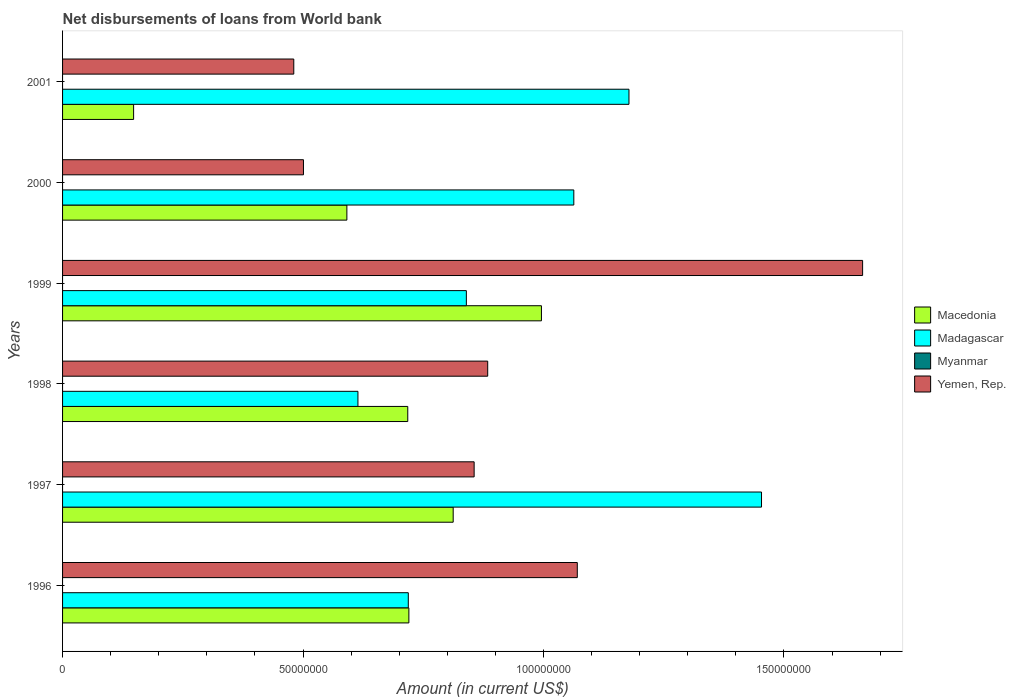How many different coloured bars are there?
Your answer should be compact. 3. How many groups of bars are there?
Give a very brief answer. 6. Are the number of bars per tick equal to the number of legend labels?
Your answer should be compact. No. How many bars are there on the 3rd tick from the top?
Your response must be concise. 3. In how many cases, is the number of bars for a given year not equal to the number of legend labels?
Offer a very short reply. 6. What is the amount of loan disbursed from World Bank in Yemen, Rep. in 1999?
Your answer should be compact. 1.66e+08. Across all years, what is the maximum amount of loan disbursed from World Bank in Macedonia?
Provide a succinct answer. 9.96e+07. Across all years, what is the minimum amount of loan disbursed from World Bank in Myanmar?
Give a very brief answer. 0. In which year was the amount of loan disbursed from World Bank in Yemen, Rep. maximum?
Provide a short and direct response. 1999. What is the total amount of loan disbursed from World Bank in Macedonia in the graph?
Ensure brevity in your answer.  3.98e+08. What is the difference between the amount of loan disbursed from World Bank in Yemen, Rep. in 1996 and that in 1997?
Provide a succinct answer. 2.14e+07. What is the difference between the amount of loan disbursed from World Bank in Myanmar in 1998 and the amount of loan disbursed from World Bank in Yemen, Rep. in 2001?
Your answer should be very brief. -4.81e+07. What is the average amount of loan disbursed from World Bank in Madagascar per year?
Provide a short and direct response. 9.78e+07. In the year 2000, what is the difference between the amount of loan disbursed from World Bank in Macedonia and amount of loan disbursed from World Bank in Madagascar?
Offer a terse response. -4.72e+07. In how many years, is the amount of loan disbursed from World Bank in Macedonia greater than 80000000 US$?
Provide a succinct answer. 2. What is the ratio of the amount of loan disbursed from World Bank in Madagascar in 1998 to that in 1999?
Your response must be concise. 0.73. Is the amount of loan disbursed from World Bank in Macedonia in 1999 less than that in 2000?
Make the answer very short. No. Is the difference between the amount of loan disbursed from World Bank in Macedonia in 1997 and 2000 greater than the difference between the amount of loan disbursed from World Bank in Madagascar in 1997 and 2000?
Your answer should be very brief. No. What is the difference between the highest and the second highest amount of loan disbursed from World Bank in Yemen, Rep.?
Provide a succinct answer. 5.93e+07. What is the difference between the highest and the lowest amount of loan disbursed from World Bank in Yemen, Rep.?
Keep it short and to the point. 1.18e+08. Is the sum of the amount of loan disbursed from World Bank in Macedonia in 1996 and 2000 greater than the maximum amount of loan disbursed from World Bank in Madagascar across all years?
Your answer should be compact. No. Is it the case that in every year, the sum of the amount of loan disbursed from World Bank in Macedonia and amount of loan disbursed from World Bank in Yemen, Rep. is greater than the sum of amount of loan disbursed from World Bank in Madagascar and amount of loan disbursed from World Bank in Myanmar?
Your response must be concise. No. How many bars are there?
Offer a very short reply. 18. How many years are there in the graph?
Keep it short and to the point. 6. Does the graph contain grids?
Ensure brevity in your answer.  No. How many legend labels are there?
Offer a terse response. 4. How are the legend labels stacked?
Give a very brief answer. Vertical. What is the title of the graph?
Ensure brevity in your answer.  Net disbursements of loans from World bank. What is the label or title of the X-axis?
Offer a terse response. Amount (in current US$). What is the Amount (in current US$) of Macedonia in 1996?
Ensure brevity in your answer.  7.20e+07. What is the Amount (in current US$) in Madagascar in 1996?
Provide a short and direct response. 7.19e+07. What is the Amount (in current US$) of Myanmar in 1996?
Provide a short and direct response. 0. What is the Amount (in current US$) in Yemen, Rep. in 1996?
Offer a very short reply. 1.07e+08. What is the Amount (in current US$) of Macedonia in 1997?
Ensure brevity in your answer.  8.12e+07. What is the Amount (in current US$) in Madagascar in 1997?
Your response must be concise. 1.45e+08. What is the Amount (in current US$) in Myanmar in 1997?
Your answer should be compact. 0. What is the Amount (in current US$) of Yemen, Rep. in 1997?
Provide a short and direct response. 8.56e+07. What is the Amount (in current US$) in Macedonia in 1998?
Provide a short and direct response. 7.18e+07. What is the Amount (in current US$) of Madagascar in 1998?
Give a very brief answer. 6.14e+07. What is the Amount (in current US$) in Yemen, Rep. in 1998?
Keep it short and to the point. 8.84e+07. What is the Amount (in current US$) of Macedonia in 1999?
Ensure brevity in your answer.  9.96e+07. What is the Amount (in current US$) in Madagascar in 1999?
Your answer should be compact. 8.40e+07. What is the Amount (in current US$) of Myanmar in 1999?
Your response must be concise. 0. What is the Amount (in current US$) of Yemen, Rep. in 1999?
Keep it short and to the point. 1.66e+08. What is the Amount (in current US$) of Macedonia in 2000?
Your answer should be compact. 5.91e+07. What is the Amount (in current US$) in Madagascar in 2000?
Make the answer very short. 1.06e+08. What is the Amount (in current US$) in Yemen, Rep. in 2000?
Ensure brevity in your answer.  5.01e+07. What is the Amount (in current US$) in Macedonia in 2001?
Give a very brief answer. 1.48e+07. What is the Amount (in current US$) of Madagascar in 2001?
Provide a short and direct response. 1.18e+08. What is the Amount (in current US$) of Yemen, Rep. in 2001?
Keep it short and to the point. 4.81e+07. Across all years, what is the maximum Amount (in current US$) of Macedonia?
Keep it short and to the point. 9.96e+07. Across all years, what is the maximum Amount (in current US$) in Madagascar?
Offer a terse response. 1.45e+08. Across all years, what is the maximum Amount (in current US$) of Yemen, Rep.?
Make the answer very short. 1.66e+08. Across all years, what is the minimum Amount (in current US$) in Macedonia?
Provide a succinct answer. 1.48e+07. Across all years, what is the minimum Amount (in current US$) in Madagascar?
Your answer should be very brief. 6.14e+07. Across all years, what is the minimum Amount (in current US$) of Yemen, Rep.?
Your answer should be compact. 4.81e+07. What is the total Amount (in current US$) of Macedonia in the graph?
Make the answer very short. 3.98e+08. What is the total Amount (in current US$) of Madagascar in the graph?
Offer a terse response. 5.87e+08. What is the total Amount (in current US$) in Yemen, Rep. in the graph?
Your answer should be very brief. 5.46e+08. What is the difference between the Amount (in current US$) of Macedonia in 1996 and that in 1997?
Make the answer very short. -9.21e+06. What is the difference between the Amount (in current US$) in Madagascar in 1996 and that in 1997?
Give a very brief answer. -7.34e+07. What is the difference between the Amount (in current US$) in Yemen, Rep. in 1996 and that in 1997?
Provide a short and direct response. 2.14e+07. What is the difference between the Amount (in current US$) in Macedonia in 1996 and that in 1998?
Ensure brevity in your answer.  2.31e+05. What is the difference between the Amount (in current US$) of Madagascar in 1996 and that in 1998?
Keep it short and to the point. 1.05e+07. What is the difference between the Amount (in current US$) of Yemen, Rep. in 1996 and that in 1998?
Your answer should be very brief. 1.86e+07. What is the difference between the Amount (in current US$) in Macedonia in 1996 and that in 1999?
Offer a terse response. -2.76e+07. What is the difference between the Amount (in current US$) of Madagascar in 1996 and that in 1999?
Your response must be concise. -1.21e+07. What is the difference between the Amount (in current US$) of Yemen, Rep. in 1996 and that in 1999?
Provide a succinct answer. -5.93e+07. What is the difference between the Amount (in current US$) in Macedonia in 1996 and that in 2000?
Make the answer very short. 1.29e+07. What is the difference between the Amount (in current US$) of Madagascar in 1996 and that in 2000?
Provide a succinct answer. -3.44e+07. What is the difference between the Amount (in current US$) in Yemen, Rep. in 1996 and that in 2000?
Make the answer very short. 5.69e+07. What is the difference between the Amount (in current US$) in Macedonia in 1996 and that in 2001?
Keep it short and to the point. 5.72e+07. What is the difference between the Amount (in current US$) in Madagascar in 1996 and that in 2001?
Your answer should be very brief. -4.59e+07. What is the difference between the Amount (in current US$) of Yemen, Rep. in 1996 and that in 2001?
Your response must be concise. 5.90e+07. What is the difference between the Amount (in current US$) of Macedonia in 1997 and that in 1998?
Your response must be concise. 9.44e+06. What is the difference between the Amount (in current US$) in Madagascar in 1997 and that in 1998?
Offer a terse response. 8.39e+07. What is the difference between the Amount (in current US$) of Yemen, Rep. in 1997 and that in 1998?
Give a very brief answer. -2.82e+06. What is the difference between the Amount (in current US$) of Macedonia in 1997 and that in 1999?
Ensure brevity in your answer.  -1.84e+07. What is the difference between the Amount (in current US$) in Madagascar in 1997 and that in 1999?
Your response must be concise. 6.14e+07. What is the difference between the Amount (in current US$) of Yemen, Rep. in 1997 and that in 1999?
Offer a very short reply. -8.08e+07. What is the difference between the Amount (in current US$) of Macedonia in 1997 and that in 2000?
Offer a terse response. 2.21e+07. What is the difference between the Amount (in current US$) in Madagascar in 1997 and that in 2000?
Offer a terse response. 3.90e+07. What is the difference between the Amount (in current US$) in Yemen, Rep. in 1997 and that in 2000?
Ensure brevity in your answer.  3.55e+07. What is the difference between the Amount (in current US$) of Macedonia in 1997 and that in 2001?
Your answer should be compact. 6.65e+07. What is the difference between the Amount (in current US$) in Madagascar in 1997 and that in 2001?
Make the answer very short. 2.76e+07. What is the difference between the Amount (in current US$) in Yemen, Rep. in 1997 and that in 2001?
Offer a very short reply. 3.75e+07. What is the difference between the Amount (in current US$) in Macedonia in 1998 and that in 1999?
Your answer should be very brief. -2.78e+07. What is the difference between the Amount (in current US$) in Madagascar in 1998 and that in 1999?
Keep it short and to the point. -2.25e+07. What is the difference between the Amount (in current US$) of Yemen, Rep. in 1998 and that in 1999?
Ensure brevity in your answer.  -7.80e+07. What is the difference between the Amount (in current US$) of Macedonia in 1998 and that in 2000?
Offer a terse response. 1.27e+07. What is the difference between the Amount (in current US$) in Madagascar in 1998 and that in 2000?
Your response must be concise. -4.49e+07. What is the difference between the Amount (in current US$) of Yemen, Rep. in 1998 and that in 2000?
Provide a succinct answer. 3.83e+07. What is the difference between the Amount (in current US$) in Macedonia in 1998 and that in 2001?
Your answer should be compact. 5.70e+07. What is the difference between the Amount (in current US$) of Madagascar in 1998 and that in 2001?
Ensure brevity in your answer.  -5.64e+07. What is the difference between the Amount (in current US$) in Yemen, Rep. in 1998 and that in 2001?
Your answer should be compact. 4.03e+07. What is the difference between the Amount (in current US$) of Macedonia in 1999 and that in 2000?
Make the answer very short. 4.05e+07. What is the difference between the Amount (in current US$) of Madagascar in 1999 and that in 2000?
Make the answer very short. -2.23e+07. What is the difference between the Amount (in current US$) of Yemen, Rep. in 1999 and that in 2000?
Make the answer very short. 1.16e+08. What is the difference between the Amount (in current US$) in Macedonia in 1999 and that in 2001?
Offer a terse response. 8.48e+07. What is the difference between the Amount (in current US$) of Madagascar in 1999 and that in 2001?
Provide a succinct answer. -3.38e+07. What is the difference between the Amount (in current US$) in Yemen, Rep. in 1999 and that in 2001?
Give a very brief answer. 1.18e+08. What is the difference between the Amount (in current US$) of Macedonia in 2000 and that in 2001?
Your response must be concise. 4.43e+07. What is the difference between the Amount (in current US$) of Madagascar in 2000 and that in 2001?
Make the answer very short. -1.15e+07. What is the difference between the Amount (in current US$) in Yemen, Rep. in 2000 and that in 2001?
Your answer should be very brief. 2.01e+06. What is the difference between the Amount (in current US$) of Macedonia in 1996 and the Amount (in current US$) of Madagascar in 1997?
Keep it short and to the point. -7.33e+07. What is the difference between the Amount (in current US$) in Macedonia in 1996 and the Amount (in current US$) in Yemen, Rep. in 1997?
Give a very brief answer. -1.36e+07. What is the difference between the Amount (in current US$) of Madagascar in 1996 and the Amount (in current US$) of Yemen, Rep. in 1997?
Your response must be concise. -1.37e+07. What is the difference between the Amount (in current US$) of Macedonia in 1996 and the Amount (in current US$) of Madagascar in 1998?
Make the answer very short. 1.06e+07. What is the difference between the Amount (in current US$) of Macedonia in 1996 and the Amount (in current US$) of Yemen, Rep. in 1998?
Your response must be concise. -1.64e+07. What is the difference between the Amount (in current US$) of Madagascar in 1996 and the Amount (in current US$) of Yemen, Rep. in 1998?
Give a very brief answer. -1.65e+07. What is the difference between the Amount (in current US$) in Macedonia in 1996 and the Amount (in current US$) in Madagascar in 1999?
Give a very brief answer. -1.20e+07. What is the difference between the Amount (in current US$) of Macedonia in 1996 and the Amount (in current US$) of Yemen, Rep. in 1999?
Provide a succinct answer. -9.43e+07. What is the difference between the Amount (in current US$) of Madagascar in 1996 and the Amount (in current US$) of Yemen, Rep. in 1999?
Your answer should be very brief. -9.45e+07. What is the difference between the Amount (in current US$) in Macedonia in 1996 and the Amount (in current US$) in Madagascar in 2000?
Your response must be concise. -3.43e+07. What is the difference between the Amount (in current US$) in Macedonia in 1996 and the Amount (in current US$) in Yemen, Rep. in 2000?
Your answer should be compact. 2.19e+07. What is the difference between the Amount (in current US$) of Madagascar in 1996 and the Amount (in current US$) of Yemen, Rep. in 2000?
Your answer should be very brief. 2.18e+07. What is the difference between the Amount (in current US$) of Macedonia in 1996 and the Amount (in current US$) of Madagascar in 2001?
Your answer should be compact. -4.58e+07. What is the difference between the Amount (in current US$) in Macedonia in 1996 and the Amount (in current US$) in Yemen, Rep. in 2001?
Give a very brief answer. 2.39e+07. What is the difference between the Amount (in current US$) of Madagascar in 1996 and the Amount (in current US$) of Yemen, Rep. in 2001?
Ensure brevity in your answer.  2.38e+07. What is the difference between the Amount (in current US$) of Macedonia in 1997 and the Amount (in current US$) of Madagascar in 1998?
Your answer should be compact. 1.98e+07. What is the difference between the Amount (in current US$) of Macedonia in 1997 and the Amount (in current US$) of Yemen, Rep. in 1998?
Give a very brief answer. -7.18e+06. What is the difference between the Amount (in current US$) of Madagascar in 1997 and the Amount (in current US$) of Yemen, Rep. in 1998?
Offer a very short reply. 5.69e+07. What is the difference between the Amount (in current US$) of Macedonia in 1997 and the Amount (in current US$) of Madagascar in 1999?
Give a very brief answer. -2.74e+06. What is the difference between the Amount (in current US$) of Macedonia in 1997 and the Amount (in current US$) of Yemen, Rep. in 1999?
Provide a succinct answer. -8.51e+07. What is the difference between the Amount (in current US$) of Madagascar in 1997 and the Amount (in current US$) of Yemen, Rep. in 1999?
Offer a very short reply. -2.10e+07. What is the difference between the Amount (in current US$) in Macedonia in 1997 and the Amount (in current US$) in Madagascar in 2000?
Offer a very short reply. -2.51e+07. What is the difference between the Amount (in current US$) in Macedonia in 1997 and the Amount (in current US$) in Yemen, Rep. in 2000?
Provide a succinct answer. 3.11e+07. What is the difference between the Amount (in current US$) in Madagascar in 1997 and the Amount (in current US$) in Yemen, Rep. in 2000?
Offer a terse response. 9.52e+07. What is the difference between the Amount (in current US$) of Macedonia in 1997 and the Amount (in current US$) of Madagascar in 2001?
Ensure brevity in your answer.  -3.66e+07. What is the difference between the Amount (in current US$) in Macedonia in 1997 and the Amount (in current US$) in Yemen, Rep. in 2001?
Keep it short and to the point. 3.31e+07. What is the difference between the Amount (in current US$) of Madagascar in 1997 and the Amount (in current US$) of Yemen, Rep. in 2001?
Your response must be concise. 9.73e+07. What is the difference between the Amount (in current US$) of Macedonia in 1998 and the Amount (in current US$) of Madagascar in 1999?
Keep it short and to the point. -1.22e+07. What is the difference between the Amount (in current US$) in Macedonia in 1998 and the Amount (in current US$) in Yemen, Rep. in 1999?
Your answer should be compact. -9.46e+07. What is the difference between the Amount (in current US$) in Madagascar in 1998 and the Amount (in current US$) in Yemen, Rep. in 1999?
Provide a succinct answer. -1.05e+08. What is the difference between the Amount (in current US$) in Macedonia in 1998 and the Amount (in current US$) in Madagascar in 2000?
Provide a short and direct response. -3.45e+07. What is the difference between the Amount (in current US$) of Macedonia in 1998 and the Amount (in current US$) of Yemen, Rep. in 2000?
Keep it short and to the point. 2.17e+07. What is the difference between the Amount (in current US$) in Madagascar in 1998 and the Amount (in current US$) in Yemen, Rep. in 2000?
Offer a very short reply. 1.13e+07. What is the difference between the Amount (in current US$) of Macedonia in 1998 and the Amount (in current US$) of Madagascar in 2001?
Offer a very short reply. -4.60e+07. What is the difference between the Amount (in current US$) of Macedonia in 1998 and the Amount (in current US$) of Yemen, Rep. in 2001?
Give a very brief answer. 2.37e+07. What is the difference between the Amount (in current US$) of Madagascar in 1998 and the Amount (in current US$) of Yemen, Rep. in 2001?
Give a very brief answer. 1.33e+07. What is the difference between the Amount (in current US$) of Macedonia in 1999 and the Amount (in current US$) of Madagascar in 2000?
Ensure brevity in your answer.  -6.73e+06. What is the difference between the Amount (in current US$) in Macedonia in 1999 and the Amount (in current US$) in Yemen, Rep. in 2000?
Give a very brief answer. 4.95e+07. What is the difference between the Amount (in current US$) of Madagascar in 1999 and the Amount (in current US$) of Yemen, Rep. in 2000?
Provide a short and direct response. 3.39e+07. What is the difference between the Amount (in current US$) in Macedonia in 1999 and the Amount (in current US$) in Madagascar in 2001?
Offer a very short reply. -1.82e+07. What is the difference between the Amount (in current US$) in Macedonia in 1999 and the Amount (in current US$) in Yemen, Rep. in 2001?
Offer a very short reply. 5.15e+07. What is the difference between the Amount (in current US$) of Madagascar in 1999 and the Amount (in current US$) of Yemen, Rep. in 2001?
Give a very brief answer. 3.59e+07. What is the difference between the Amount (in current US$) of Macedonia in 2000 and the Amount (in current US$) of Madagascar in 2001?
Ensure brevity in your answer.  -5.87e+07. What is the difference between the Amount (in current US$) in Macedonia in 2000 and the Amount (in current US$) in Yemen, Rep. in 2001?
Give a very brief answer. 1.10e+07. What is the difference between the Amount (in current US$) of Madagascar in 2000 and the Amount (in current US$) of Yemen, Rep. in 2001?
Your answer should be very brief. 5.82e+07. What is the average Amount (in current US$) of Macedonia per year?
Offer a terse response. 6.64e+07. What is the average Amount (in current US$) of Madagascar per year?
Provide a succinct answer. 9.78e+07. What is the average Amount (in current US$) of Myanmar per year?
Provide a short and direct response. 0. What is the average Amount (in current US$) of Yemen, Rep. per year?
Provide a succinct answer. 9.09e+07. In the year 1996, what is the difference between the Amount (in current US$) in Macedonia and Amount (in current US$) in Madagascar?
Provide a succinct answer. 1.19e+05. In the year 1996, what is the difference between the Amount (in current US$) in Macedonia and Amount (in current US$) in Yemen, Rep.?
Your response must be concise. -3.50e+07. In the year 1996, what is the difference between the Amount (in current US$) of Madagascar and Amount (in current US$) of Yemen, Rep.?
Make the answer very short. -3.51e+07. In the year 1997, what is the difference between the Amount (in current US$) of Macedonia and Amount (in current US$) of Madagascar?
Give a very brief answer. -6.41e+07. In the year 1997, what is the difference between the Amount (in current US$) of Macedonia and Amount (in current US$) of Yemen, Rep.?
Your answer should be very brief. -4.36e+06. In the year 1997, what is the difference between the Amount (in current US$) of Madagascar and Amount (in current US$) of Yemen, Rep.?
Your response must be concise. 5.98e+07. In the year 1998, what is the difference between the Amount (in current US$) of Macedonia and Amount (in current US$) of Madagascar?
Your answer should be very brief. 1.04e+07. In the year 1998, what is the difference between the Amount (in current US$) in Macedonia and Amount (in current US$) in Yemen, Rep.?
Provide a short and direct response. -1.66e+07. In the year 1998, what is the difference between the Amount (in current US$) of Madagascar and Amount (in current US$) of Yemen, Rep.?
Ensure brevity in your answer.  -2.70e+07. In the year 1999, what is the difference between the Amount (in current US$) of Macedonia and Amount (in current US$) of Madagascar?
Your response must be concise. 1.56e+07. In the year 1999, what is the difference between the Amount (in current US$) of Macedonia and Amount (in current US$) of Yemen, Rep.?
Give a very brief answer. -6.68e+07. In the year 1999, what is the difference between the Amount (in current US$) of Madagascar and Amount (in current US$) of Yemen, Rep.?
Your response must be concise. -8.24e+07. In the year 2000, what is the difference between the Amount (in current US$) of Macedonia and Amount (in current US$) of Madagascar?
Your response must be concise. -4.72e+07. In the year 2000, what is the difference between the Amount (in current US$) of Macedonia and Amount (in current US$) of Yemen, Rep.?
Your response must be concise. 9.03e+06. In the year 2000, what is the difference between the Amount (in current US$) in Madagascar and Amount (in current US$) in Yemen, Rep.?
Ensure brevity in your answer.  5.62e+07. In the year 2001, what is the difference between the Amount (in current US$) in Macedonia and Amount (in current US$) in Madagascar?
Offer a terse response. -1.03e+08. In the year 2001, what is the difference between the Amount (in current US$) of Macedonia and Amount (in current US$) of Yemen, Rep.?
Make the answer very short. -3.33e+07. In the year 2001, what is the difference between the Amount (in current US$) of Madagascar and Amount (in current US$) of Yemen, Rep.?
Ensure brevity in your answer.  6.97e+07. What is the ratio of the Amount (in current US$) of Macedonia in 1996 to that in 1997?
Your answer should be very brief. 0.89. What is the ratio of the Amount (in current US$) of Madagascar in 1996 to that in 1997?
Provide a succinct answer. 0.49. What is the ratio of the Amount (in current US$) in Yemen, Rep. in 1996 to that in 1997?
Offer a very short reply. 1.25. What is the ratio of the Amount (in current US$) of Madagascar in 1996 to that in 1998?
Give a very brief answer. 1.17. What is the ratio of the Amount (in current US$) in Yemen, Rep. in 1996 to that in 1998?
Provide a short and direct response. 1.21. What is the ratio of the Amount (in current US$) of Macedonia in 1996 to that in 1999?
Your response must be concise. 0.72. What is the ratio of the Amount (in current US$) in Madagascar in 1996 to that in 1999?
Your response must be concise. 0.86. What is the ratio of the Amount (in current US$) of Yemen, Rep. in 1996 to that in 1999?
Ensure brevity in your answer.  0.64. What is the ratio of the Amount (in current US$) of Macedonia in 1996 to that in 2000?
Offer a terse response. 1.22. What is the ratio of the Amount (in current US$) in Madagascar in 1996 to that in 2000?
Give a very brief answer. 0.68. What is the ratio of the Amount (in current US$) in Yemen, Rep. in 1996 to that in 2000?
Ensure brevity in your answer.  2.14. What is the ratio of the Amount (in current US$) of Macedonia in 1996 to that in 2001?
Give a very brief answer. 4.88. What is the ratio of the Amount (in current US$) in Madagascar in 1996 to that in 2001?
Offer a terse response. 0.61. What is the ratio of the Amount (in current US$) in Yemen, Rep. in 1996 to that in 2001?
Your answer should be compact. 2.23. What is the ratio of the Amount (in current US$) of Macedonia in 1997 to that in 1998?
Your answer should be compact. 1.13. What is the ratio of the Amount (in current US$) in Madagascar in 1997 to that in 1998?
Your answer should be very brief. 2.37. What is the ratio of the Amount (in current US$) in Yemen, Rep. in 1997 to that in 1998?
Your answer should be very brief. 0.97. What is the ratio of the Amount (in current US$) of Macedonia in 1997 to that in 1999?
Your answer should be very brief. 0.82. What is the ratio of the Amount (in current US$) of Madagascar in 1997 to that in 1999?
Provide a succinct answer. 1.73. What is the ratio of the Amount (in current US$) in Yemen, Rep. in 1997 to that in 1999?
Your response must be concise. 0.51. What is the ratio of the Amount (in current US$) in Macedonia in 1997 to that in 2000?
Your answer should be compact. 1.37. What is the ratio of the Amount (in current US$) in Madagascar in 1997 to that in 2000?
Provide a short and direct response. 1.37. What is the ratio of the Amount (in current US$) in Yemen, Rep. in 1997 to that in 2000?
Keep it short and to the point. 1.71. What is the ratio of the Amount (in current US$) in Macedonia in 1997 to that in 2001?
Provide a succinct answer. 5.5. What is the ratio of the Amount (in current US$) in Madagascar in 1997 to that in 2001?
Offer a very short reply. 1.23. What is the ratio of the Amount (in current US$) of Yemen, Rep. in 1997 to that in 2001?
Ensure brevity in your answer.  1.78. What is the ratio of the Amount (in current US$) in Macedonia in 1998 to that in 1999?
Your answer should be compact. 0.72. What is the ratio of the Amount (in current US$) in Madagascar in 1998 to that in 1999?
Provide a short and direct response. 0.73. What is the ratio of the Amount (in current US$) in Yemen, Rep. in 1998 to that in 1999?
Offer a terse response. 0.53. What is the ratio of the Amount (in current US$) of Macedonia in 1998 to that in 2000?
Provide a succinct answer. 1.21. What is the ratio of the Amount (in current US$) in Madagascar in 1998 to that in 2000?
Ensure brevity in your answer.  0.58. What is the ratio of the Amount (in current US$) of Yemen, Rep. in 1998 to that in 2000?
Provide a succinct answer. 1.76. What is the ratio of the Amount (in current US$) of Macedonia in 1998 to that in 2001?
Give a very brief answer. 4.86. What is the ratio of the Amount (in current US$) of Madagascar in 1998 to that in 2001?
Provide a short and direct response. 0.52. What is the ratio of the Amount (in current US$) in Yemen, Rep. in 1998 to that in 2001?
Your answer should be very brief. 1.84. What is the ratio of the Amount (in current US$) in Macedonia in 1999 to that in 2000?
Give a very brief answer. 1.68. What is the ratio of the Amount (in current US$) of Madagascar in 1999 to that in 2000?
Provide a short and direct response. 0.79. What is the ratio of the Amount (in current US$) of Yemen, Rep. in 1999 to that in 2000?
Keep it short and to the point. 3.32. What is the ratio of the Amount (in current US$) in Macedonia in 1999 to that in 2001?
Offer a terse response. 6.74. What is the ratio of the Amount (in current US$) in Madagascar in 1999 to that in 2001?
Your answer should be very brief. 0.71. What is the ratio of the Amount (in current US$) in Yemen, Rep. in 1999 to that in 2001?
Provide a short and direct response. 3.46. What is the ratio of the Amount (in current US$) of Macedonia in 2000 to that in 2001?
Your answer should be very brief. 4. What is the ratio of the Amount (in current US$) of Madagascar in 2000 to that in 2001?
Give a very brief answer. 0.9. What is the ratio of the Amount (in current US$) in Yemen, Rep. in 2000 to that in 2001?
Provide a succinct answer. 1.04. What is the difference between the highest and the second highest Amount (in current US$) in Macedonia?
Make the answer very short. 1.84e+07. What is the difference between the highest and the second highest Amount (in current US$) of Madagascar?
Ensure brevity in your answer.  2.76e+07. What is the difference between the highest and the second highest Amount (in current US$) in Yemen, Rep.?
Offer a very short reply. 5.93e+07. What is the difference between the highest and the lowest Amount (in current US$) of Macedonia?
Make the answer very short. 8.48e+07. What is the difference between the highest and the lowest Amount (in current US$) in Madagascar?
Your answer should be compact. 8.39e+07. What is the difference between the highest and the lowest Amount (in current US$) in Yemen, Rep.?
Your answer should be compact. 1.18e+08. 